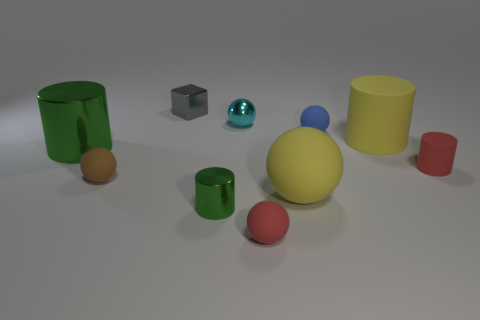What materials do these objects seem to be made of? The objects in the image seem to be made of different materials. The shiny sphere appears to be metallic, likely steel or aluminum, while the cylinders and cubes seem to have a matte finish, resembling plastic or rubber. The larger yellow cylinder and the green cup exhibit a slight sheen, suggesting they might be a softer kind of plastic or rubber. 